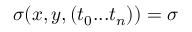Convert formula to latex. <formula><loc_0><loc_0><loc_500><loc_500>\sigma ( x , y , ( t _ { 0 } \dots t _ { n } ) ) = \sigma</formula> 